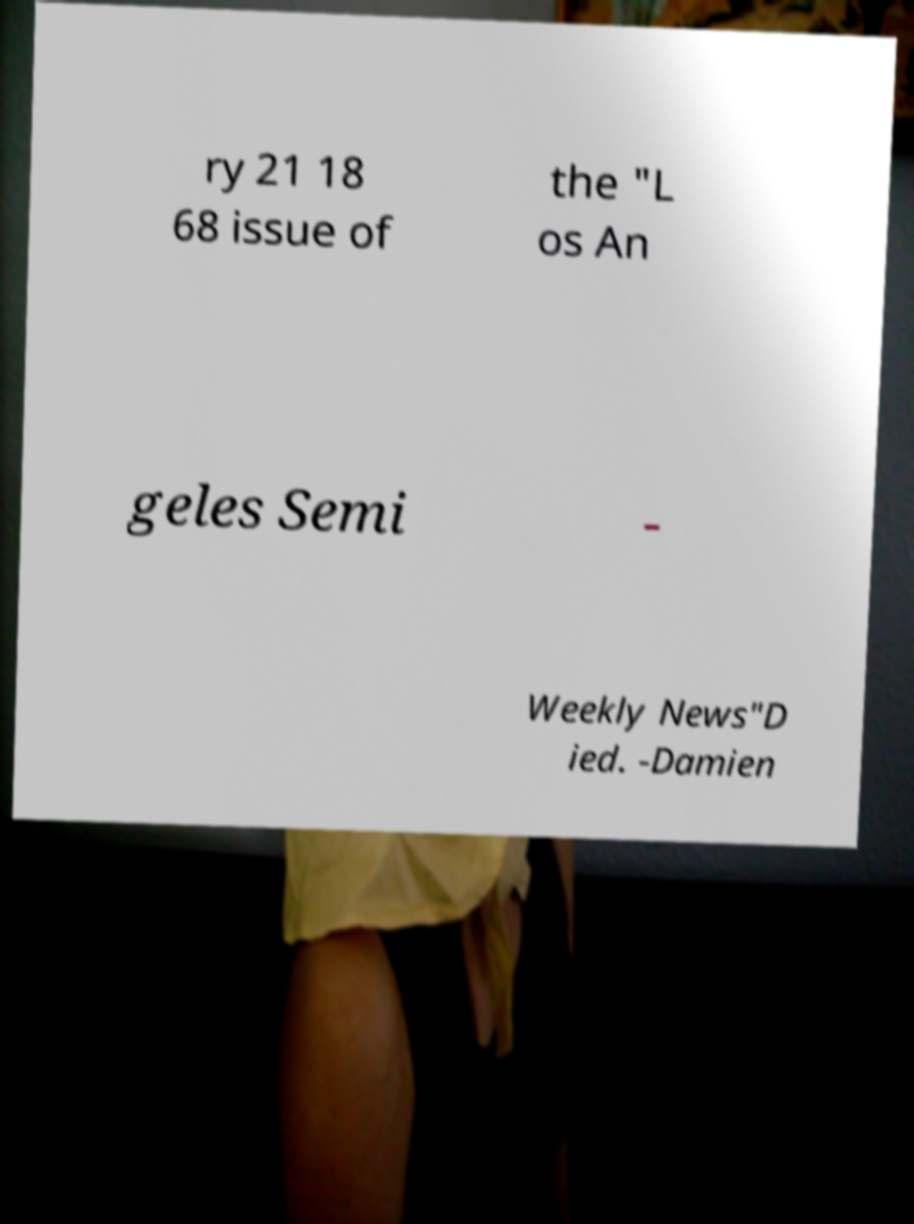I need the written content from this picture converted into text. Can you do that? ry 21 18 68 issue of the "L os An geles Semi - Weekly News"D ied. -Damien 